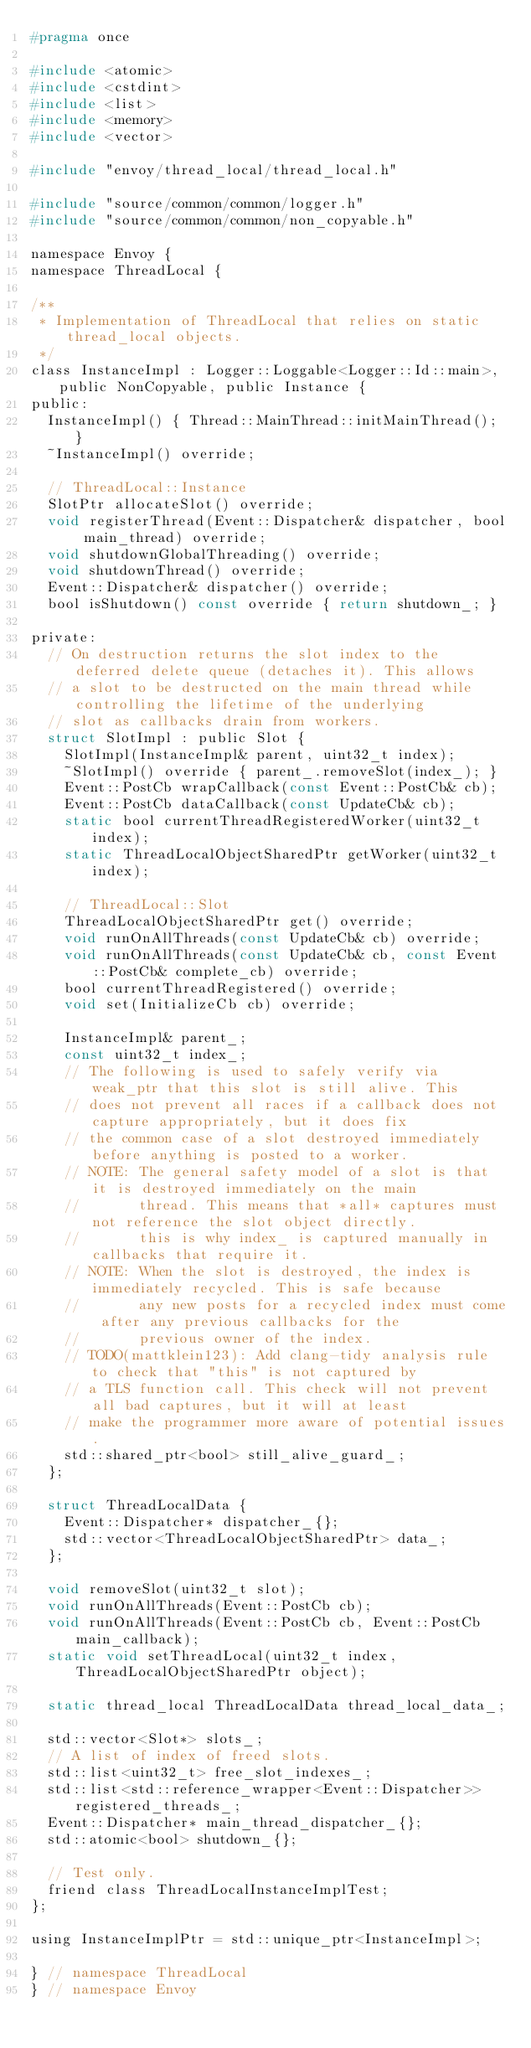<code> <loc_0><loc_0><loc_500><loc_500><_C_>#pragma once

#include <atomic>
#include <cstdint>
#include <list>
#include <memory>
#include <vector>

#include "envoy/thread_local/thread_local.h"

#include "source/common/common/logger.h"
#include "source/common/common/non_copyable.h"

namespace Envoy {
namespace ThreadLocal {

/**
 * Implementation of ThreadLocal that relies on static thread_local objects.
 */
class InstanceImpl : Logger::Loggable<Logger::Id::main>, public NonCopyable, public Instance {
public:
  InstanceImpl() { Thread::MainThread::initMainThread(); }
  ~InstanceImpl() override;

  // ThreadLocal::Instance
  SlotPtr allocateSlot() override;
  void registerThread(Event::Dispatcher& dispatcher, bool main_thread) override;
  void shutdownGlobalThreading() override;
  void shutdownThread() override;
  Event::Dispatcher& dispatcher() override;
  bool isShutdown() const override { return shutdown_; }

private:
  // On destruction returns the slot index to the deferred delete queue (detaches it). This allows
  // a slot to be destructed on the main thread while controlling the lifetime of the underlying
  // slot as callbacks drain from workers.
  struct SlotImpl : public Slot {
    SlotImpl(InstanceImpl& parent, uint32_t index);
    ~SlotImpl() override { parent_.removeSlot(index_); }
    Event::PostCb wrapCallback(const Event::PostCb& cb);
    Event::PostCb dataCallback(const UpdateCb& cb);
    static bool currentThreadRegisteredWorker(uint32_t index);
    static ThreadLocalObjectSharedPtr getWorker(uint32_t index);

    // ThreadLocal::Slot
    ThreadLocalObjectSharedPtr get() override;
    void runOnAllThreads(const UpdateCb& cb) override;
    void runOnAllThreads(const UpdateCb& cb, const Event::PostCb& complete_cb) override;
    bool currentThreadRegistered() override;
    void set(InitializeCb cb) override;

    InstanceImpl& parent_;
    const uint32_t index_;
    // The following is used to safely verify via weak_ptr that this slot is still alive. This
    // does not prevent all races if a callback does not capture appropriately, but it does fix
    // the common case of a slot destroyed immediately before anything is posted to a worker.
    // NOTE: The general safety model of a slot is that it is destroyed immediately on the main
    //       thread. This means that *all* captures must not reference the slot object directly.
    //       this is why index_ is captured manually in callbacks that require it.
    // NOTE: When the slot is destroyed, the index is immediately recycled. This is safe because
    //       any new posts for a recycled index must come after any previous callbacks for the
    //       previous owner of the index.
    // TODO(mattklein123): Add clang-tidy analysis rule to check that "this" is not captured by
    // a TLS function call. This check will not prevent all bad captures, but it will at least
    // make the programmer more aware of potential issues.
    std::shared_ptr<bool> still_alive_guard_;
  };

  struct ThreadLocalData {
    Event::Dispatcher* dispatcher_{};
    std::vector<ThreadLocalObjectSharedPtr> data_;
  };

  void removeSlot(uint32_t slot);
  void runOnAllThreads(Event::PostCb cb);
  void runOnAllThreads(Event::PostCb cb, Event::PostCb main_callback);
  static void setThreadLocal(uint32_t index, ThreadLocalObjectSharedPtr object);

  static thread_local ThreadLocalData thread_local_data_;

  std::vector<Slot*> slots_;
  // A list of index of freed slots.
  std::list<uint32_t> free_slot_indexes_;
  std::list<std::reference_wrapper<Event::Dispatcher>> registered_threads_;
  Event::Dispatcher* main_thread_dispatcher_{};
  std::atomic<bool> shutdown_{};

  // Test only.
  friend class ThreadLocalInstanceImplTest;
};

using InstanceImplPtr = std::unique_ptr<InstanceImpl>;

} // namespace ThreadLocal
} // namespace Envoy
</code> 